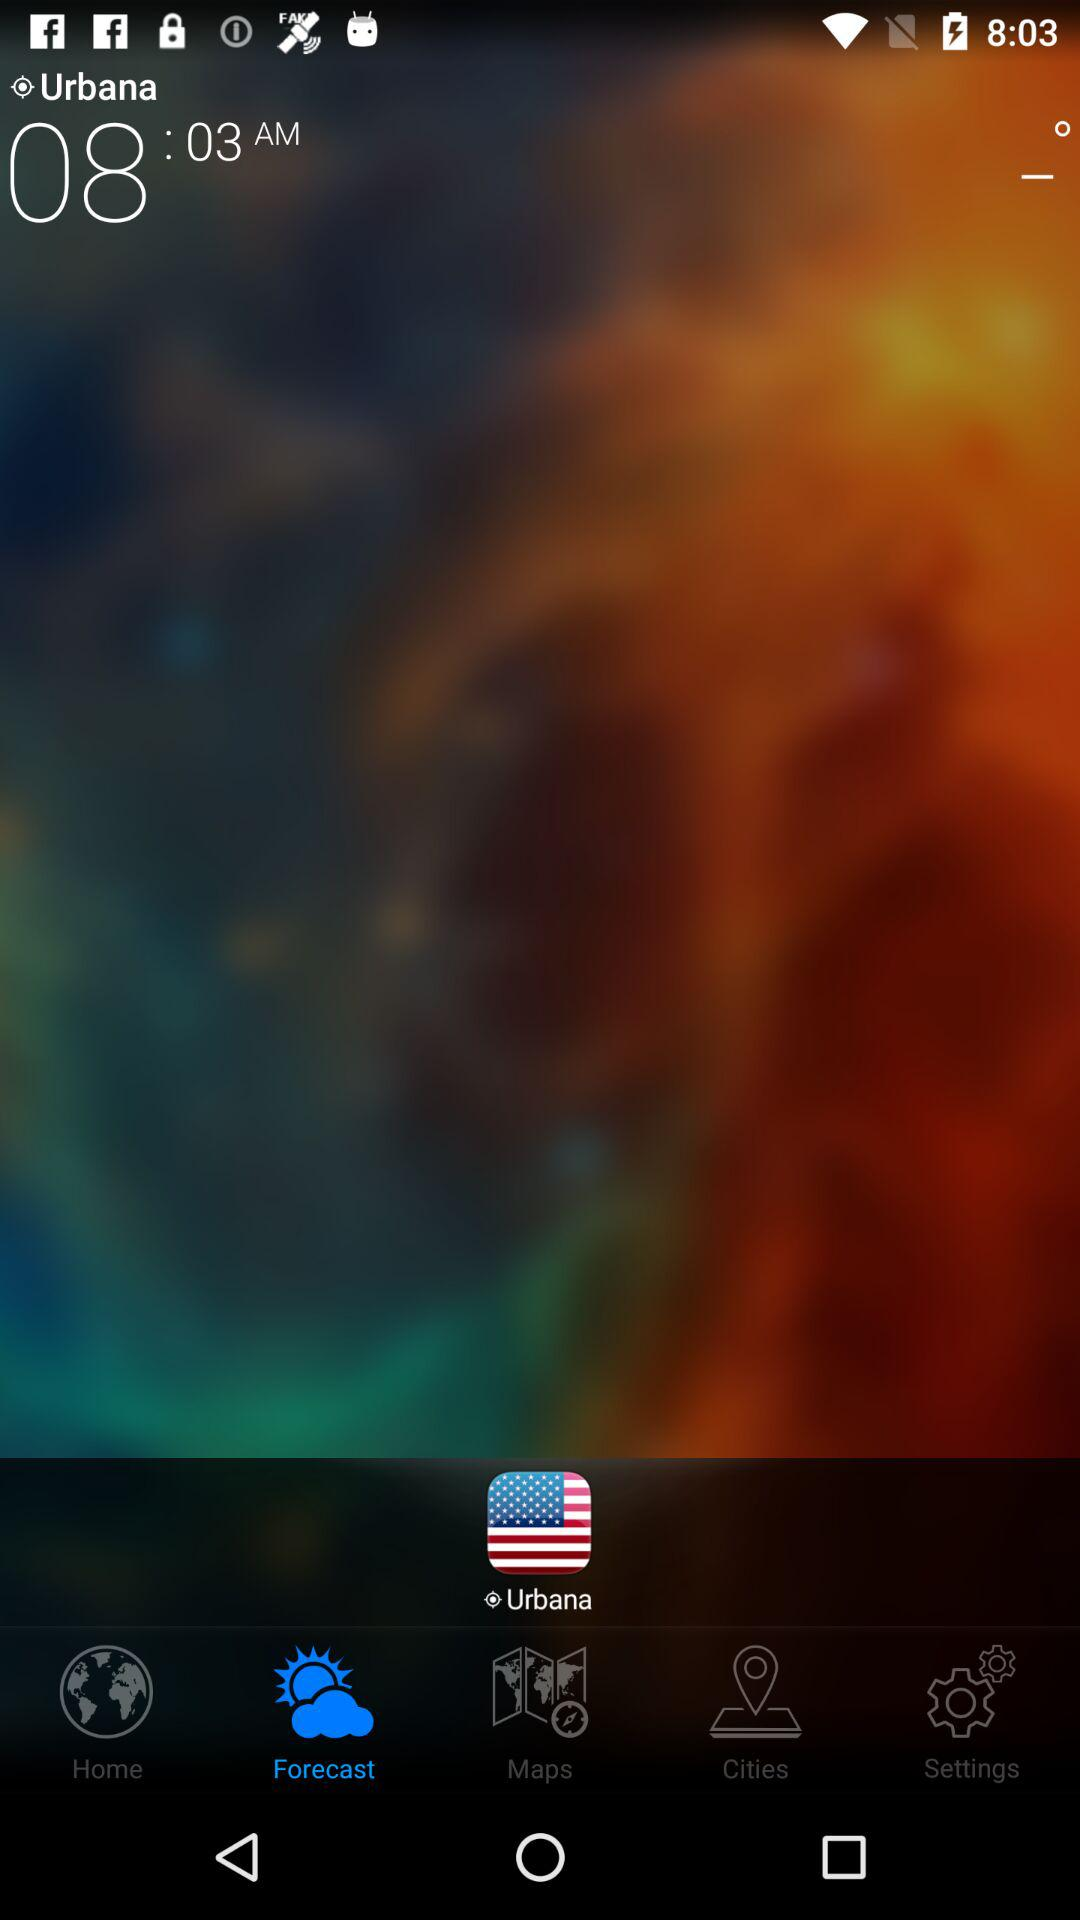What location is given? The given location is Urbana. 